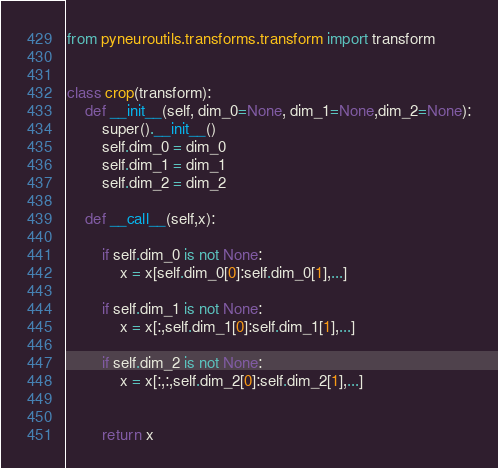<code> <loc_0><loc_0><loc_500><loc_500><_Python_>from pyneuroutils.transforms.transform import transform


class crop(transform):
    def __init__(self, dim_0=None, dim_1=None,dim_2=None):
        super().__init__()
        self.dim_0 = dim_0
        self.dim_1 = dim_1
        self.dim_2 = dim_2

    def __call__(self,x):

        if self.dim_0 is not None:
            x = x[self.dim_0[0]:self.dim_0[1],...]

        if self.dim_1 is not None:
            x = x[:,self.dim_1[0]:self.dim_1[1],...]

        if self.dim_2 is not None:
            x = x[:,:,self.dim_2[0]:self.dim_2[1],...]


        return x</code> 